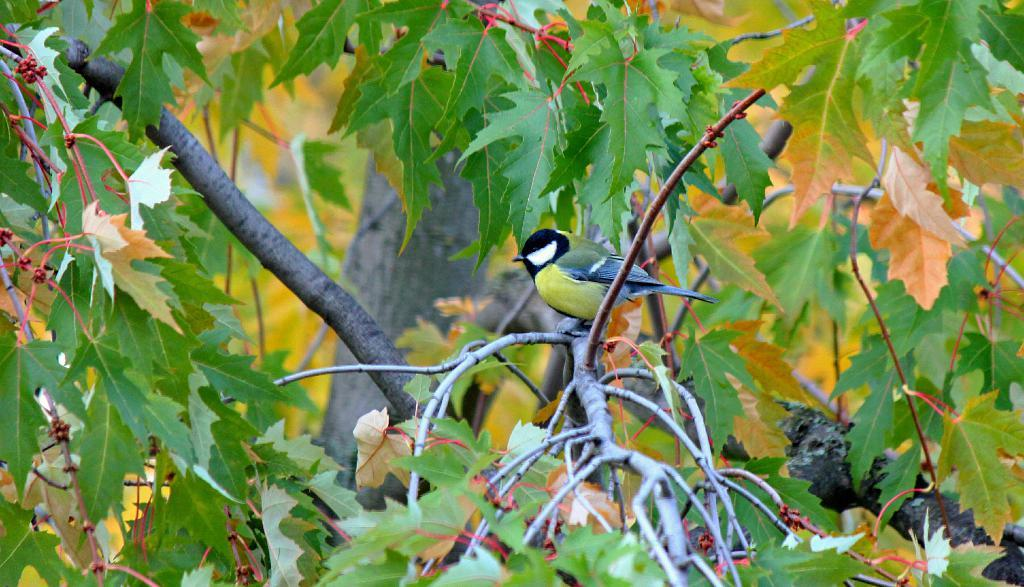What is the main subject in the center of the image? There is a bird in the center of the image. Where is the bird located? The bird is sitting on a tree. What can be seen in the background of the image? There is a tree and leaves visible in the background of the image. What type of prose can be heard being read by the bird in the image? There is no indication in the image that the bird is reading any prose, as birds do not have the ability to read or speak. --- Facts: 1. There is a car in the image. 2. The car is parked on the street. 3. There are streetlights visible in the image. 4. The street is paved. Absurd Topics: dance, piano, ocean Conversation: What is the main subject in the image? There is a car in the image. Where is the car located? The car is parked on the street. What can be seen in the background of the image? There are streetlights visible in the image. What type of surface is the street made of? The street is paved. Reasoning: Let's think step by step in order to produce the conversation. We start by identifying the main subject in the image, which is the car. Then, we describe the car's location, which is parked on the street. Next, we mention the background elements, which include streetlights. Finally, we describe the street's surface, which is paved. Each question is designed to elicit a specific detail about the image that is known from the provided facts. Absurd Question/Answer: Can you hear the sound of the ocean in the background of the image? There is no indication of the ocean or any ocean sounds in the image, as it features a car parked on the street with streetlights in the background. 